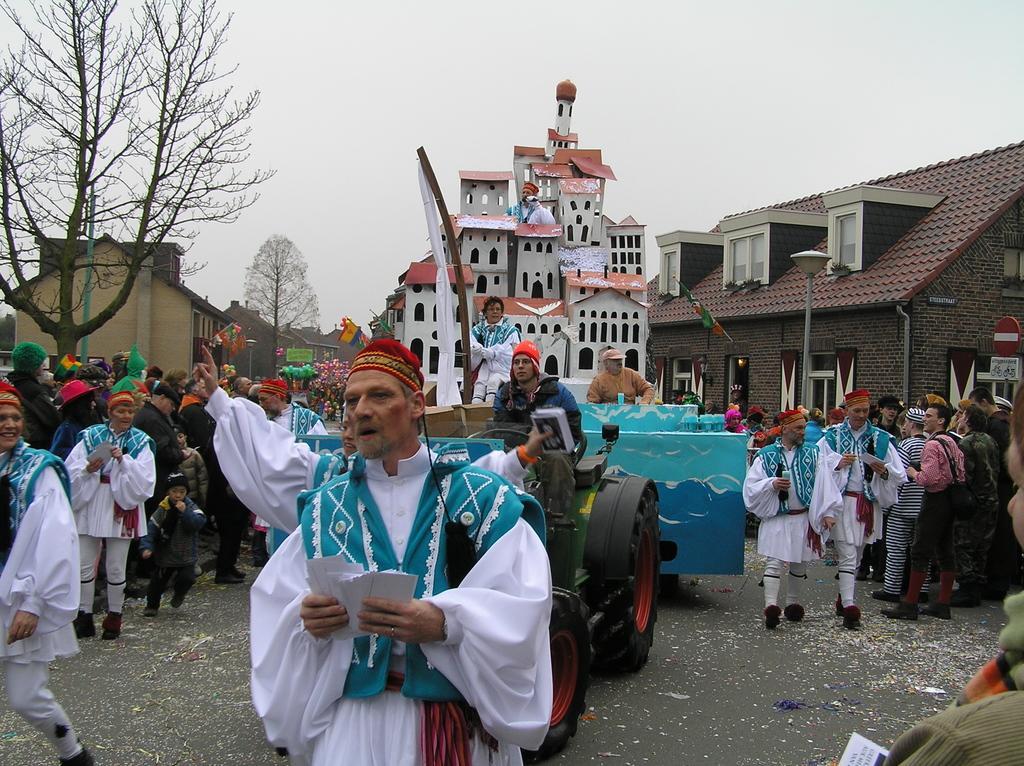Describe this image in one or two sentences. There are few persons wearing white and blue dress and there is a vehicle behind them and there are few people and buildings on either sides of them and there are trees in the left corner. 